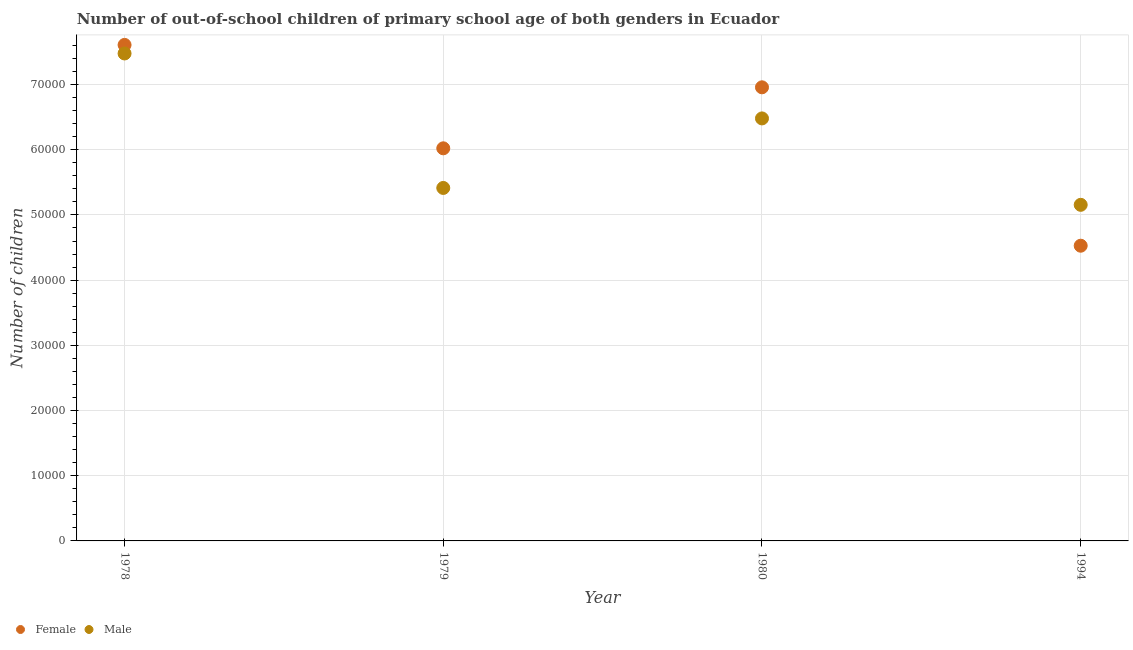What is the number of male out-of-school students in 1994?
Offer a very short reply. 5.15e+04. Across all years, what is the maximum number of male out-of-school students?
Provide a succinct answer. 7.48e+04. Across all years, what is the minimum number of female out-of-school students?
Offer a very short reply. 4.53e+04. In which year was the number of male out-of-school students maximum?
Make the answer very short. 1978. What is the total number of male out-of-school students in the graph?
Ensure brevity in your answer.  2.45e+05. What is the difference between the number of male out-of-school students in 1978 and that in 1994?
Make the answer very short. 2.32e+04. What is the difference between the number of female out-of-school students in 1979 and the number of male out-of-school students in 1978?
Offer a very short reply. -1.45e+04. What is the average number of female out-of-school students per year?
Provide a short and direct response. 6.28e+04. In the year 1979, what is the difference between the number of male out-of-school students and number of female out-of-school students?
Ensure brevity in your answer.  -6079. What is the ratio of the number of female out-of-school students in 1978 to that in 1980?
Keep it short and to the point. 1.09. Is the difference between the number of female out-of-school students in 1978 and 1979 greater than the difference between the number of male out-of-school students in 1978 and 1979?
Your answer should be very brief. No. What is the difference between the highest and the second highest number of male out-of-school students?
Your answer should be very brief. 9961. What is the difference between the highest and the lowest number of female out-of-school students?
Your answer should be very brief. 3.08e+04. Is the number of female out-of-school students strictly greater than the number of male out-of-school students over the years?
Keep it short and to the point. No. How many years are there in the graph?
Ensure brevity in your answer.  4. What is the difference between two consecutive major ticks on the Y-axis?
Provide a short and direct response. 10000. Are the values on the major ticks of Y-axis written in scientific E-notation?
Provide a succinct answer. No. Does the graph contain any zero values?
Provide a short and direct response. No. Does the graph contain grids?
Your answer should be compact. Yes. Where does the legend appear in the graph?
Offer a terse response. Bottom left. How many legend labels are there?
Provide a short and direct response. 2. What is the title of the graph?
Keep it short and to the point. Number of out-of-school children of primary school age of both genders in Ecuador. Does "Export" appear as one of the legend labels in the graph?
Provide a succinct answer. No. What is the label or title of the Y-axis?
Make the answer very short. Number of children. What is the Number of children in Female in 1978?
Offer a very short reply. 7.61e+04. What is the Number of children in Male in 1978?
Your response must be concise. 7.48e+04. What is the Number of children in Female in 1979?
Your answer should be compact. 6.02e+04. What is the Number of children of Male in 1979?
Provide a short and direct response. 5.41e+04. What is the Number of children in Female in 1980?
Your answer should be compact. 6.96e+04. What is the Number of children of Male in 1980?
Your response must be concise. 6.48e+04. What is the Number of children of Female in 1994?
Offer a terse response. 4.53e+04. What is the Number of children of Male in 1994?
Make the answer very short. 5.15e+04. Across all years, what is the maximum Number of children in Female?
Make the answer very short. 7.61e+04. Across all years, what is the maximum Number of children of Male?
Provide a succinct answer. 7.48e+04. Across all years, what is the minimum Number of children of Female?
Your answer should be very brief. 4.53e+04. Across all years, what is the minimum Number of children of Male?
Provide a succinct answer. 5.15e+04. What is the total Number of children in Female in the graph?
Provide a succinct answer. 2.51e+05. What is the total Number of children in Male in the graph?
Make the answer very short. 2.45e+05. What is the difference between the Number of children of Female in 1978 and that in 1979?
Offer a very short reply. 1.59e+04. What is the difference between the Number of children of Male in 1978 and that in 1979?
Your response must be concise. 2.06e+04. What is the difference between the Number of children in Female in 1978 and that in 1980?
Provide a succinct answer. 6503. What is the difference between the Number of children of Male in 1978 and that in 1980?
Make the answer very short. 9961. What is the difference between the Number of children in Female in 1978 and that in 1994?
Your answer should be compact. 3.08e+04. What is the difference between the Number of children of Male in 1978 and that in 1994?
Your answer should be very brief. 2.32e+04. What is the difference between the Number of children in Female in 1979 and that in 1980?
Your answer should be compact. -9356. What is the difference between the Number of children of Male in 1979 and that in 1980?
Provide a succinct answer. -1.07e+04. What is the difference between the Number of children of Female in 1979 and that in 1994?
Provide a succinct answer. 1.49e+04. What is the difference between the Number of children of Male in 1979 and that in 1994?
Provide a succinct answer. 2588. What is the difference between the Number of children of Female in 1980 and that in 1994?
Your answer should be compact. 2.43e+04. What is the difference between the Number of children of Male in 1980 and that in 1994?
Give a very brief answer. 1.33e+04. What is the difference between the Number of children in Female in 1978 and the Number of children in Male in 1979?
Offer a terse response. 2.19e+04. What is the difference between the Number of children in Female in 1978 and the Number of children in Male in 1980?
Make the answer very short. 1.13e+04. What is the difference between the Number of children of Female in 1978 and the Number of children of Male in 1994?
Offer a very short reply. 2.45e+04. What is the difference between the Number of children in Female in 1979 and the Number of children in Male in 1980?
Provide a short and direct response. -4585. What is the difference between the Number of children in Female in 1979 and the Number of children in Male in 1994?
Give a very brief answer. 8667. What is the difference between the Number of children of Female in 1980 and the Number of children of Male in 1994?
Give a very brief answer. 1.80e+04. What is the average Number of children in Female per year?
Provide a short and direct response. 6.28e+04. What is the average Number of children in Male per year?
Offer a very short reply. 6.13e+04. In the year 1978, what is the difference between the Number of children of Female and Number of children of Male?
Your answer should be very brief. 1313. In the year 1979, what is the difference between the Number of children of Female and Number of children of Male?
Provide a succinct answer. 6079. In the year 1980, what is the difference between the Number of children in Female and Number of children in Male?
Provide a succinct answer. 4771. In the year 1994, what is the difference between the Number of children in Female and Number of children in Male?
Provide a succinct answer. -6272. What is the ratio of the Number of children of Female in 1978 to that in 1979?
Your answer should be compact. 1.26. What is the ratio of the Number of children of Male in 1978 to that in 1979?
Your answer should be compact. 1.38. What is the ratio of the Number of children of Female in 1978 to that in 1980?
Your answer should be very brief. 1.09. What is the ratio of the Number of children in Male in 1978 to that in 1980?
Your answer should be compact. 1.15. What is the ratio of the Number of children in Female in 1978 to that in 1994?
Your response must be concise. 1.68. What is the ratio of the Number of children of Male in 1978 to that in 1994?
Your answer should be very brief. 1.45. What is the ratio of the Number of children of Female in 1979 to that in 1980?
Give a very brief answer. 0.87. What is the ratio of the Number of children of Male in 1979 to that in 1980?
Give a very brief answer. 0.84. What is the ratio of the Number of children of Female in 1979 to that in 1994?
Make the answer very short. 1.33. What is the ratio of the Number of children of Male in 1979 to that in 1994?
Your answer should be very brief. 1.05. What is the ratio of the Number of children in Female in 1980 to that in 1994?
Provide a succinct answer. 1.54. What is the ratio of the Number of children in Male in 1980 to that in 1994?
Your response must be concise. 1.26. What is the difference between the highest and the second highest Number of children of Female?
Offer a terse response. 6503. What is the difference between the highest and the second highest Number of children in Male?
Your response must be concise. 9961. What is the difference between the highest and the lowest Number of children of Female?
Give a very brief answer. 3.08e+04. What is the difference between the highest and the lowest Number of children in Male?
Make the answer very short. 2.32e+04. 